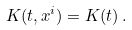Convert formula to latex. <formula><loc_0><loc_0><loc_500><loc_500>K ( t , x ^ { i } ) = K ( t ) \, .</formula> 